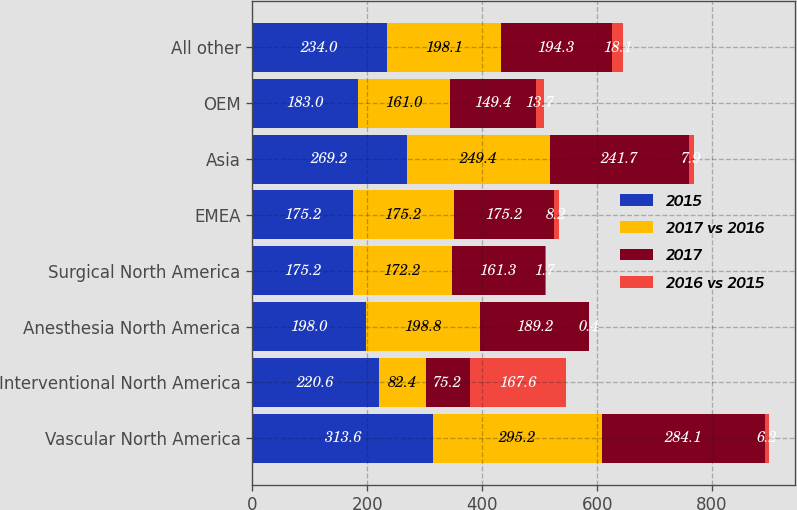Convert chart to OTSL. <chart><loc_0><loc_0><loc_500><loc_500><stacked_bar_chart><ecel><fcel>Vascular North America<fcel>Interventional North America<fcel>Anesthesia North America<fcel>Surgical North America<fcel>EMEA<fcel>Asia<fcel>OEM<fcel>All other<nl><fcel>2015<fcel>313.6<fcel>220.6<fcel>198<fcel>175.2<fcel>175.2<fcel>269.2<fcel>183<fcel>234<nl><fcel>2017 vs 2016<fcel>295.2<fcel>82.4<fcel>198.8<fcel>172.2<fcel>175.2<fcel>249.4<fcel>161<fcel>198.1<nl><fcel>2017<fcel>284.1<fcel>75.2<fcel>189.2<fcel>161.3<fcel>175.2<fcel>241.7<fcel>149.4<fcel>194.3<nl><fcel>2016 vs 2015<fcel>6.2<fcel>167.6<fcel>0.4<fcel>1.7<fcel>8.2<fcel>7.9<fcel>13.7<fcel>18.1<nl></chart> 